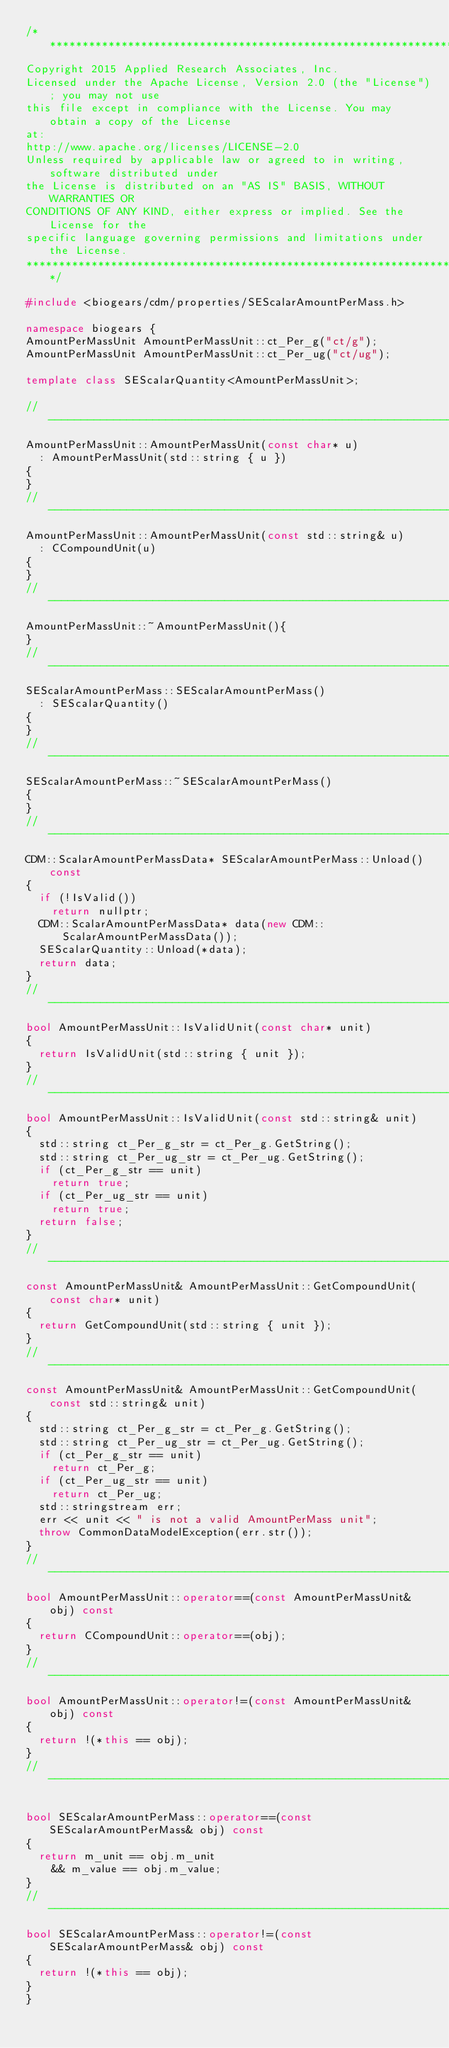<code> <loc_0><loc_0><loc_500><loc_500><_C++_>/**************************************************************************************
Copyright 2015 Applied Research Associates, Inc.
Licensed under the Apache License, Version 2.0 (the "License"); you may not use
this file except in compliance with the License. You may obtain a copy of the License
at:
http://www.apache.org/licenses/LICENSE-2.0
Unless required by applicable law or agreed to in writing, software distributed under
the License is distributed on an "AS IS" BASIS, WITHOUT WARRANTIES OR
CONDITIONS OF ANY KIND, either express or implied. See the License for the
specific language governing permissions and limitations under the License.
**************************************************************************************/

#include <biogears/cdm/properties/SEScalarAmountPerMass.h>

namespace biogears {
AmountPerMassUnit AmountPerMassUnit::ct_Per_g("ct/g");
AmountPerMassUnit AmountPerMassUnit::ct_Per_ug("ct/ug");

template class SEScalarQuantity<AmountPerMassUnit>;

//-----------------------------------------------------------------------------
AmountPerMassUnit::AmountPerMassUnit(const char* u)
  : AmountPerMassUnit(std::string { u })
{
}
//-----------------------------------------------------------------------------
AmountPerMassUnit::AmountPerMassUnit(const std::string& u)
  : CCompoundUnit(u)
{
}
//-----------------------------------------------------------------------------
AmountPerMassUnit::~AmountPerMassUnit(){
}
//-----------------------------------------------------------------------------
SEScalarAmountPerMass::SEScalarAmountPerMass()
  : SEScalarQuantity()
{
}
//-----------------------------------------------------------------------------
SEScalarAmountPerMass::~SEScalarAmountPerMass()
{
}
//-----------------------------------------------------------------------------
CDM::ScalarAmountPerMassData* SEScalarAmountPerMass::Unload() const
{
  if (!IsValid())
    return nullptr;
  CDM::ScalarAmountPerMassData* data(new CDM::ScalarAmountPerMassData());
  SEScalarQuantity::Unload(*data);
  return data;
}
//-----------------------------------------------------------------------------
bool AmountPerMassUnit::IsValidUnit(const char* unit)
{
  return IsValidUnit(std::string { unit });
}
//-----------------------------------------------------------------------------
bool AmountPerMassUnit::IsValidUnit(const std::string& unit)
{
  std::string ct_Per_g_str = ct_Per_g.GetString();
  std::string ct_Per_ug_str = ct_Per_ug.GetString();
  if (ct_Per_g_str == unit)
    return true;
  if (ct_Per_ug_str == unit)
    return true;
  return false;
}
//-----------------------------------------------------------------------------
const AmountPerMassUnit& AmountPerMassUnit::GetCompoundUnit(const char* unit)
{
  return GetCompoundUnit(std::string { unit });
}
//-----------------------------------------------------------------------------
const AmountPerMassUnit& AmountPerMassUnit::GetCompoundUnit(const std::string& unit)
{
  std::string ct_Per_g_str = ct_Per_g.GetString();
  std::string ct_Per_ug_str = ct_Per_ug.GetString();
  if (ct_Per_g_str == unit)
    return ct_Per_g;
  if (ct_Per_ug_str == unit)
    return ct_Per_ug;
  std::stringstream err;
  err << unit << " is not a valid AmountPerMass unit";
  throw CommonDataModelException(err.str());
}
//-----------------------------------------------------------------------------
bool AmountPerMassUnit::operator==(const AmountPerMassUnit& obj) const
{
  return CCompoundUnit::operator==(obj);
}
//-------------------------------------------------------------------------------
bool AmountPerMassUnit::operator!=(const AmountPerMassUnit& obj) const
{
  return !(*this == obj);
}
//-------------------------------------------------------------------------------

bool SEScalarAmountPerMass::operator==(const SEScalarAmountPerMass& obj) const
{
  return m_unit == obj.m_unit
    && m_value == obj.m_value;
}
//-------------------------------------------------------------------------------
bool SEScalarAmountPerMass::operator!=(const SEScalarAmountPerMass& obj) const
{
  return !(*this == obj);
}
}</code> 